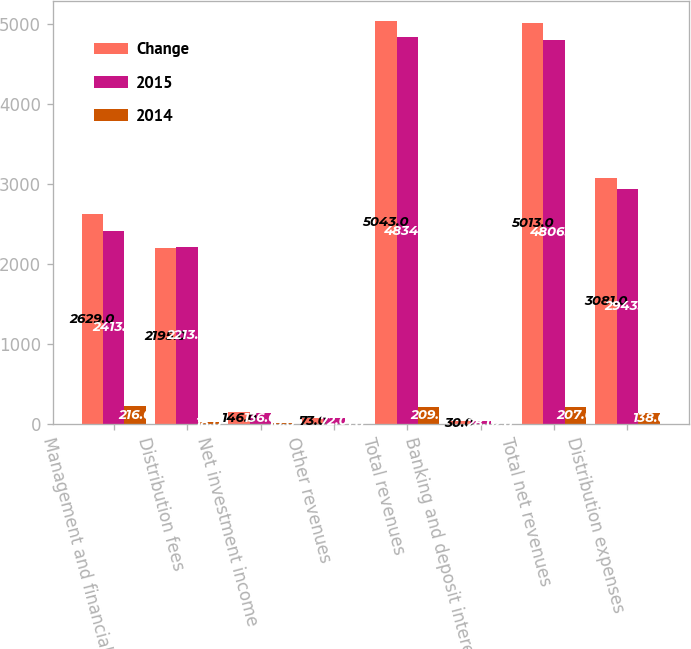Convert chart. <chart><loc_0><loc_0><loc_500><loc_500><stacked_bar_chart><ecel><fcel>Management and financial<fcel>Distribution fees<fcel>Net investment income<fcel>Other revenues<fcel>Total revenues<fcel>Banking and deposit interest<fcel>Total net revenues<fcel>Distribution expenses<nl><fcel>Change<fcel>2629<fcel>2195<fcel>146<fcel>73<fcel>5043<fcel>30<fcel>5013<fcel>3081<nl><fcel>2015<fcel>2413<fcel>2213<fcel>136<fcel>72<fcel>4834<fcel>28<fcel>4806<fcel>2943<nl><fcel>2014<fcel>216<fcel>18<fcel>10<fcel>1<fcel>209<fcel>2<fcel>207<fcel>138<nl></chart> 